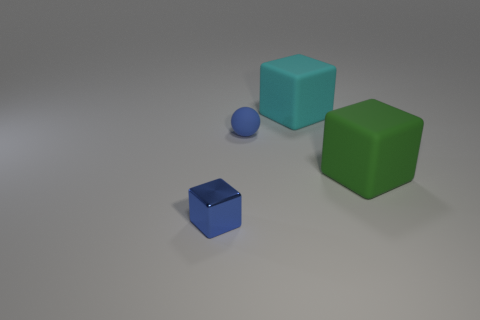There is a object that is the same color as the sphere; what material is it?
Give a very brief answer. Metal. There is a small sphere; is its color the same as the thing that is in front of the green matte cube?
Provide a short and direct response. Yes. What is the material of the other large thing that is the same shape as the cyan rubber object?
Offer a terse response. Rubber. Are there any other things that have the same material as the small cube?
Provide a succinct answer. No. Does the matte sphere have the same color as the shiny object?
Provide a succinct answer. Yes. The other tiny thing that is made of the same material as the cyan object is what shape?
Your answer should be compact. Sphere. What number of large matte objects have the same shape as the metallic object?
Keep it short and to the point. 2. What shape is the tiny rubber object behind the cube to the left of the small sphere?
Your response must be concise. Sphere. Does the rubber cube in front of the blue rubber sphere have the same size as the large cyan object?
Provide a succinct answer. Yes. There is a thing that is on the left side of the cyan rubber object and behind the small blue metallic thing; what size is it?
Offer a very short reply. Small. 